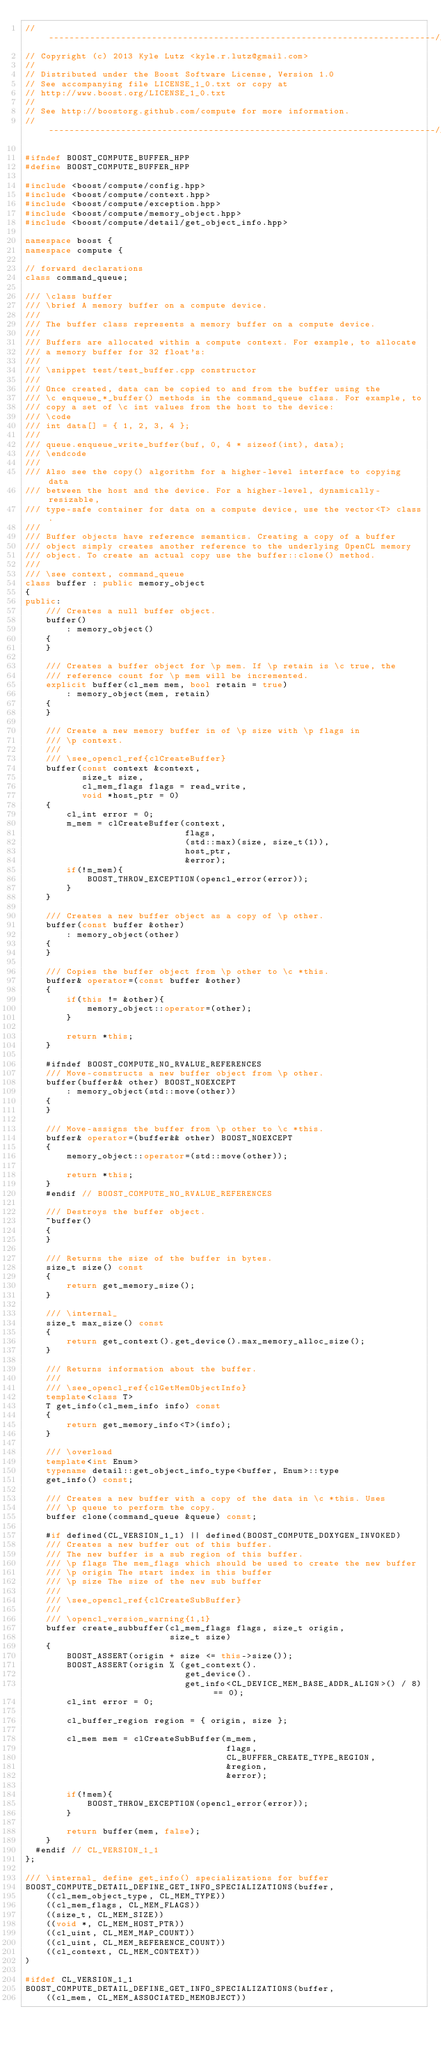<code> <loc_0><loc_0><loc_500><loc_500><_C++_>//---------------------------------------------------------------------------//
// Copyright (c) 2013 Kyle Lutz <kyle.r.lutz@gmail.com>
//
// Distributed under the Boost Software License, Version 1.0
// See accompanying file LICENSE_1_0.txt or copy at
// http://www.boost.org/LICENSE_1_0.txt
//
// See http://boostorg.github.com/compute for more information.
//---------------------------------------------------------------------------//

#ifndef BOOST_COMPUTE_BUFFER_HPP
#define BOOST_COMPUTE_BUFFER_HPP

#include <boost/compute/config.hpp>
#include <boost/compute/context.hpp>
#include <boost/compute/exception.hpp>
#include <boost/compute/memory_object.hpp>
#include <boost/compute/detail/get_object_info.hpp>

namespace boost {
namespace compute {

// forward declarations
class command_queue;

/// \class buffer
/// \brief A memory buffer on a compute device.
///
/// The buffer class represents a memory buffer on a compute device.
///
/// Buffers are allocated within a compute context. For example, to allocate
/// a memory buffer for 32 float's:
///
/// \snippet test/test_buffer.cpp constructor
///
/// Once created, data can be copied to and from the buffer using the
/// \c enqueue_*_buffer() methods in the command_queue class. For example, to
/// copy a set of \c int values from the host to the device:
/// \code
/// int data[] = { 1, 2, 3, 4 };
///
/// queue.enqueue_write_buffer(buf, 0, 4 * sizeof(int), data);
/// \endcode
///
/// Also see the copy() algorithm for a higher-level interface to copying data
/// between the host and the device. For a higher-level, dynamically-resizable,
/// type-safe container for data on a compute device, use the vector<T> class.
///
/// Buffer objects have reference semantics. Creating a copy of a buffer
/// object simply creates another reference to the underlying OpenCL memory
/// object. To create an actual copy use the buffer::clone() method.
///
/// \see context, command_queue
class buffer : public memory_object
{
public:
    /// Creates a null buffer object.
    buffer()
        : memory_object()
    {
    }

    /// Creates a buffer object for \p mem. If \p retain is \c true, the
    /// reference count for \p mem will be incremented.
    explicit buffer(cl_mem mem, bool retain = true)
        : memory_object(mem, retain)
    {
    }

    /// Create a new memory buffer in of \p size with \p flags in
    /// \p context.
    ///
    /// \see_opencl_ref{clCreateBuffer}
    buffer(const context &context,
           size_t size,
           cl_mem_flags flags = read_write,
           void *host_ptr = 0)
    {
        cl_int error = 0;
        m_mem = clCreateBuffer(context,
                               flags,
                               (std::max)(size, size_t(1)),
                               host_ptr,
                               &error);
        if(!m_mem){
            BOOST_THROW_EXCEPTION(opencl_error(error));
        }
    }

    /// Creates a new buffer object as a copy of \p other.
    buffer(const buffer &other)
        : memory_object(other)
    {
    }

    /// Copies the buffer object from \p other to \c *this.
    buffer& operator=(const buffer &other)
    {
        if(this != &other){
            memory_object::operator=(other);
        }

        return *this;
    }

    #ifndef BOOST_COMPUTE_NO_RVALUE_REFERENCES
    /// Move-constructs a new buffer object from \p other.
    buffer(buffer&& other) BOOST_NOEXCEPT
        : memory_object(std::move(other))
    {
    }

    /// Move-assigns the buffer from \p other to \c *this.
    buffer& operator=(buffer&& other) BOOST_NOEXCEPT
    {
        memory_object::operator=(std::move(other));

        return *this;
    }
    #endif // BOOST_COMPUTE_NO_RVALUE_REFERENCES

    /// Destroys the buffer object.
    ~buffer()
    {
    }

    /// Returns the size of the buffer in bytes.
    size_t size() const
    {
        return get_memory_size();
    }

    /// \internal_
    size_t max_size() const
    {
        return get_context().get_device().max_memory_alloc_size();
    }

    /// Returns information about the buffer.
    ///
    /// \see_opencl_ref{clGetMemObjectInfo}
    template<class T>
    T get_info(cl_mem_info info) const
    {
        return get_memory_info<T>(info);
    }

    /// \overload
    template<int Enum>
    typename detail::get_object_info_type<buffer, Enum>::type
    get_info() const;

    /// Creates a new buffer with a copy of the data in \c *this. Uses
    /// \p queue to perform the copy.
    buffer clone(command_queue &queue) const;

    #if defined(CL_VERSION_1_1) || defined(BOOST_COMPUTE_DOXYGEN_INVOKED)
    /// Creates a new buffer out of this buffer.
    /// The new buffer is a sub region of this buffer.
    /// \p flags The mem_flags which should be used to create the new buffer
    /// \p origin The start index in this buffer
    /// \p size The size of the new sub buffer
    ///
    /// \see_opencl_ref{clCreateSubBuffer}
    ///
    /// \opencl_version_warning{1,1}
    buffer create_subbuffer(cl_mem_flags flags, size_t origin,
                            size_t size)
    {
        BOOST_ASSERT(origin + size <= this->size());
        BOOST_ASSERT(origin % (get_context().
                               get_device().
                               get_info<CL_DEVICE_MEM_BASE_ADDR_ALIGN>() / 8) == 0);
        cl_int error = 0;

        cl_buffer_region region = { origin, size };

        cl_mem mem = clCreateSubBuffer(m_mem,
                                       flags,
                                       CL_BUFFER_CREATE_TYPE_REGION,
                                       &region,
                                       &error);

        if(!mem){
            BOOST_THROW_EXCEPTION(opencl_error(error));
        }

        return buffer(mem, false);
    }
  #endif // CL_VERSION_1_1
};

/// \internal_ define get_info() specializations for buffer
BOOST_COMPUTE_DETAIL_DEFINE_GET_INFO_SPECIALIZATIONS(buffer,
    ((cl_mem_object_type, CL_MEM_TYPE))
    ((cl_mem_flags, CL_MEM_FLAGS))
    ((size_t, CL_MEM_SIZE))
    ((void *, CL_MEM_HOST_PTR))
    ((cl_uint, CL_MEM_MAP_COUNT))
    ((cl_uint, CL_MEM_REFERENCE_COUNT))
    ((cl_context, CL_MEM_CONTEXT))
)

#ifdef CL_VERSION_1_1
BOOST_COMPUTE_DETAIL_DEFINE_GET_INFO_SPECIALIZATIONS(buffer,
    ((cl_mem, CL_MEM_ASSOCIATED_MEMOBJECT))</code> 